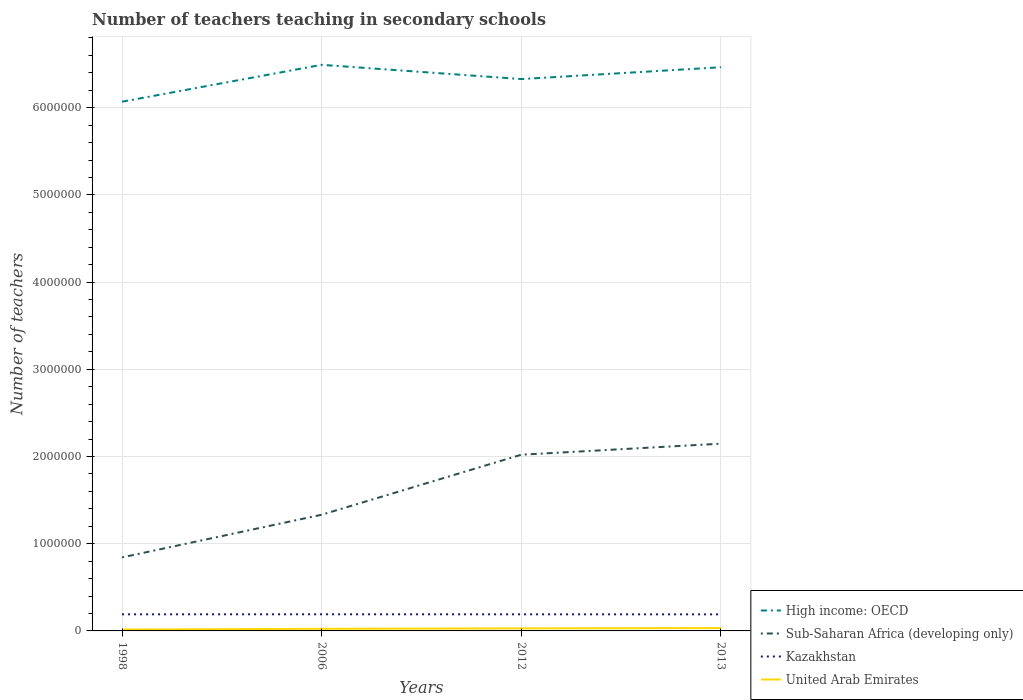Does the line corresponding to High income: OECD intersect with the line corresponding to Kazakhstan?
Provide a short and direct response. No. Across all years, what is the maximum number of teachers teaching in secondary schools in United Arab Emirates?
Offer a very short reply. 1.56e+04. What is the total number of teachers teaching in secondary schools in Kazakhstan in the graph?
Your response must be concise. 504. What is the difference between the highest and the second highest number of teachers teaching in secondary schools in United Arab Emirates?
Give a very brief answer. 1.71e+04. How many lines are there?
Your response must be concise. 4. What is the difference between two consecutive major ticks on the Y-axis?
Your answer should be compact. 1.00e+06. Are the values on the major ticks of Y-axis written in scientific E-notation?
Your answer should be compact. No. Does the graph contain any zero values?
Make the answer very short. No. What is the title of the graph?
Provide a short and direct response. Number of teachers teaching in secondary schools. Does "Peru" appear as one of the legend labels in the graph?
Keep it short and to the point. No. What is the label or title of the X-axis?
Give a very brief answer. Years. What is the label or title of the Y-axis?
Make the answer very short. Number of teachers. What is the Number of teachers of High income: OECD in 1998?
Your answer should be compact. 6.07e+06. What is the Number of teachers of Sub-Saharan Africa (developing only) in 1998?
Offer a terse response. 8.43e+05. What is the Number of teachers of Kazakhstan in 1998?
Your response must be concise. 1.90e+05. What is the Number of teachers in United Arab Emirates in 1998?
Your response must be concise. 1.56e+04. What is the Number of teachers of High income: OECD in 2006?
Make the answer very short. 6.49e+06. What is the Number of teachers in Sub-Saharan Africa (developing only) in 2006?
Make the answer very short. 1.33e+06. What is the Number of teachers in Kazakhstan in 2006?
Your answer should be compact. 1.91e+05. What is the Number of teachers in United Arab Emirates in 2006?
Your answer should be very brief. 2.42e+04. What is the Number of teachers of High income: OECD in 2012?
Your answer should be compact. 6.33e+06. What is the Number of teachers of Sub-Saharan Africa (developing only) in 2012?
Provide a short and direct response. 2.02e+06. What is the Number of teachers of Kazakhstan in 2012?
Provide a succinct answer. 1.90e+05. What is the Number of teachers in United Arab Emirates in 2012?
Your answer should be very brief. 2.93e+04. What is the Number of teachers in High income: OECD in 2013?
Your answer should be very brief. 6.46e+06. What is the Number of teachers of Sub-Saharan Africa (developing only) in 2013?
Provide a succinct answer. 2.15e+06. What is the Number of teachers in Kazakhstan in 2013?
Provide a short and direct response. 1.90e+05. What is the Number of teachers in United Arab Emirates in 2013?
Offer a terse response. 3.27e+04. Across all years, what is the maximum Number of teachers in High income: OECD?
Offer a very short reply. 6.49e+06. Across all years, what is the maximum Number of teachers of Sub-Saharan Africa (developing only)?
Your response must be concise. 2.15e+06. Across all years, what is the maximum Number of teachers in Kazakhstan?
Provide a succinct answer. 1.91e+05. Across all years, what is the maximum Number of teachers in United Arab Emirates?
Offer a very short reply. 3.27e+04. Across all years, what is the minimum Number of teachers of High income: OECD?
Give a very brief answer. 6.07e+06. Across all years, what is the minimum Number of teachers of Sub-Saharan Africa (developing only)?
Your answer should be very brief. 8.43e+05. Across all years, what is the minimum Number of teachers in Kazakhstan?
Give a very brief answer. 1.90e+05. Across all years, what is the minimum Number of teachers of United Arab Emirates?
Provide a succinct answer. 1.56e+04. What is the total Number of teachers of High income: OECD in the graph?
Give a very brief answer. 2.54e+07. What is the total Number of teachers in Sub-Saharan Africa (developing only) in the graph?
Make the answer very short. 6.34e+06. What is the total Number of teachers in Kazakhstan in the graph?
Provide a short and direct response. 7.62e+05. What is the total Number of teachers of United Arab Emirates in the graph?
Your answer should be compact. 1.02e+05. What is the difference between the Number of teachers of High income: OECD in 1998 and that in 2006?
Offer a terse response. -4.23e+05. What is the difference between the Number of teachers of Sub-Saharan Africa (developing only) in 1998 and that in 2006?
Your response must be concise. -4.89e+05. What is the difference between the Number of teachers in Kazakhstan in 1998 and that in 2006?
Your answer should be compact. -324. What is the difference between the Number of teachers in United Arab Emirates in 1998 and that in 2006?
Keep it short and to the point. -8642. What is the difference between the Number of teachers in High income: OECD in 1998 and that in 2012?
Provide a succinct answer. -2.59e+05. What is the difference between the Number of teachers in Sub-Saharan Africa (developing only) in 1998 and that in 2012?
Make the answer very short. -1.18e+06. What is the difference between the Number of teachers of Kazakhstan in 1998 and that in 2012?
Give a very brief answer. -23. What is the difference between the Number of teachers of United Arab Emirates in 1998 and that in 2012?
Provide a succinct answer. -1.37e+04. What is the difference between the Number of teachers in High income: OECD in 1998 and that in 2013?
Your answer should be compact. -3.95e+05. What is the difference between the Number of teachers in Sub-Saharan Africa (developing only) in 1998 and that in 2013?
Keep it short and to the point. -1.30e+06. What is the difference between the Number of teachers of Kazakhstan in 1998 and that in 2013?
Provide a succinct answer. 481. What is the difference between the Number of teachers in United Arab Emirates in 1998 and that in 2013?
Provide a short and direct response. -1.71e+04. What is the difference between the Number of teachers in High income: OECD in 2006 and that in 2012?
Provide a succinct answer. 1.64e+05. What is the difference between the Number of teachers of Sub-Saharan Africa (developing only) in 2006 and that in 2012?
Make the answer very short. -6.88e+05. What is the difference between the Number of teachers in Kazakhstan in 2006 and that in 2012?
Keep it short and to the point. 301. What is the difference between the Number of teachers of United Arab Emirates in 2006 and that in 2012?
Keep it short and to the point. -5061. What is the difference between the Number of teachers in High income: OECD in 2006 and that in 2013?
Make the answer very short. 2.78e+04. What is the difference between the Number of teachers of Sub-Saharan Africa (developing only) in 2006 and that in 2013?
Your answer should be very brief. -8.15e+05. What is the difference between the Number of teachers in Kazakhstan in 2006 and that in 2013?
Give a very brief answer. 805. What is the difference between the Number of teachers of United Arab Emirates in 2006 and that in 2013?
Offer a terse response. -8488. What is the difference between the Number of teachers in High income: OECD in 2012 and that in 2013?
Give a very brief answer. -1.36e+05. What is the difference between the Number of teachers of Sub-Saharan Africa (developing only) in 2012 and that in 2013?
Your answer should be very brief. -1.27e+05. What is the difference between the Number of teachers of Kazakhstan in 2012 and that in 2013?
Ensure brevity in your answer.  504. What is the difference between the Number of teachers of United Arab Emirates in 2012 and that in 2013?
Give a very brief answer. -3427. What is the difference between the Number of teachers in High income: OECD in 1998 and the Number of teachers in Sub-Saharan Africa (developing only) in 2006?
Offer a terse response. 4.74e+06. What is the difference between the Number of teachers of High income: OECD in 1998 and the Number of teachers of Kazakhstan in 2006?
Make the answer very short. 5.88e+06. What is the difference between the Number of teachers in High income: OECD in 1998 and the Number of teachers in United Arab Emirates in 2006?
Offer a very short reply. 6.04e+06. What is the difference between the Number of teachers in Sub-Saharan Africa (developing only) in 1998 and the Number of teachers in Kazakhstan in 2006?
Offer a terse response. 6.53e+05. What is the difference between the Number of teachers in Sub-Saharan Africa (developing only) in 1998 and the Number of teachers in United Arab Emirates in 2006?
Your answer should be very brief. 8.19e+05. What is the difference between the Number of teachers in Kazakhstan in 1998 and the Number of teachers in United Arab Emirates in 2006?
Keep it short and to the point. 1.66e+05. What is the difference between the Number of teachers in High income: OECD in 1998 and the Number of teachers in Sub-Saharan Africa (developing only) in 2012?
Your response must be concise. 4.05e+06. What is the difference between the Number of teachers in High income: OECD in 1998 and the Number of teachers in Kazakhstan in 2012?
Provide a succinct answer. 5.88e+06. What is the difference between the Number of teachers in High income: OECD in 1998 and the Number of teachers in United Arab Emirates in 2012?
Ensure brevity in your answer.  6.04e+06. What is the difference between the Number of teachers in Sub-Saharan Africa (developing only) in 1998 and the Number of teachers in Kazakhstan in 2012?
Offer a terse response. 6.53e+05. What is the difference between the Number of teachers in Sub-Saharan Africa (developing only) in 1998 and the Number of teachers in United Arab Emirates in 2012?
Provide a short and direct response. 8.14e+05. What is the difference between the Number of teachers of Kazakhstan in 1998 and the Number of teachers of United Arab Emirates in 2012?
Provide a succinct answer. 1.61e+05. What is the difference between the Number of teachers in High income: OECD in 1998 and the Number of teachers in Sub-Saharan Africa (developing only) in 2013?
Offer a terse response. 3.92e+06. What is the difference between the Number of teachers of High income: OECD in 1998 and the Number of teachers of Kazakhstan in 2013?
Your answer should be very brief. 5.88e+06. What is the difference between the Number of teachers of High income: OECD in 1998 and the Number of teachers of United Arab Emirates in 2013?
Provide a succinct answer. 6.04e+06. What is the difference between the Number of teachers in Sub-Saharan Africa (developing only) in 1998 and the Number of teachers in Kazakhstan in 2013?
Provide a succinct answer. 6.53e+05. What is the difference between the Number of teachers in Sub-Saharan Africa (developing only) in 1998 and the Number of teachers in United Arab Emirates in 2013?
Keep it short and to the point. 8.11e+05. What is the difference between the Number of teachers of Kazakhstan in 1998 and the Number of teachers of United Arab Emirates in 2013?
Ensure brevity in your answer.  1.58e+05. What is the difference between the Number of teachers in High income: OECD in 2006 and the Number of teachers in Sub-Saharan Africa (developing only) in 2012?
Keep it short and to the point. 4.47e+06. What is the difference between the Number of teachers in High income: OECD in 2006 and the Number of teachers in Kazakhstan in 2012?
Provide a short and direct response. 6.30e+06. What is the difference between the Number of teachers of High income: OECD in 2006 and the Number of teachers of United Arab Emirates in 2012?
Your answer should be compact. 6.46e+06. What is the difference between the Number of teachers in Sub-Saharan Africa (developing only) in 2006 and the Number of teachers in Kazakhstan in 2012?
Your response must be concise. 1.14e+06. What is the difference between the Number of teachers of Sub-Saharan Africa (developing only) in 2006 and the Number of teachers of United Arab Emirates in 2012?
Offer a terse response. 1.30e+06. What is the difference between the Number of teachers in Kazakhstan in 2006 and the Number of teachers in United Arab Emirates in 2012?
Make the answer very short. 1.62e+05. What is the difference between the Number of teachers of High income: OECD in 2006 and the Number of teachers of Sub-Saharan Africa (developing only) in 2013?
Provide a short and direct response. 4.34e+06. What is the difference between the Number of teachers of High income: OECD in 2006 and the Number of teachers of Kazakhstan in 2013?
Offer a terse response. 6.30e+06. What is the difference between the Number of teachers in High income: OECD in 2006 and the Number of teachers in United Arab Emirates in 2013?
Make the answer very short. 6.46e+06. What is the difference between the Number of teachers in Sub-Saharan Africa (developing only) in 2006 and the Number of teachers in Kazakhstan in 2013?
Keep it short and to the point. 1.14e+06. What is the difference between the Number of teachers in Sub-Saharan Africa (developing only) in 2006 and the Number of teachers in United Arab Emirates in 2013?
Ensure brevity in your answer.  1.30e+06. What is the difference between the Number of teachers of Kazakhstan in 2006 and the Number of teachers of United Arab Emirates in 2013?
Make the answer very short. 1.58e+05. What is the difference between the Number of teachers in High income: OECD in 2012 and the Number of teachers in Sub-Saharan Africa (developing only) in 2013?
Make the answer very short. 4.18e+06. What is the difference between the Number of teachers of High income: OECD in 2012 and the Number of teachers of Kazakhstan in 2013?
Provide a short and direct response. 6.14e+06. What is the difference between the Number of teachers of High income: OECD in 2012 and the Number of teachers of United Arab Emirates in 2013?
Provide a short and direct response. 6.30e+06. What is the difference between the Number of teachers in Sub-Saharan Africa (developing only) in 2012 and the Number of teachers in Kazakhstan in 2013?
Make the answer very short. 1.83e+06. What is the difference between the Number of teachers in Sub-Saharan Africa (developing only) in 2012 and the Number of teachers in United Arab Emirates in 2013?
Ensure brevity in your answer.  1.99e+06. What is the difference between the Number of teachers in Kazakhstan in 2012 and the Number of teachers in United Arab Emirates in 2013?
Your response must be concise. 1.58e+05. What is the average Number of teachers in High income: OECD per year?
Provide a succinct answer. 6.34e+06. What is the average Number of teachers of Sub-Saharan Africa (developing only) per year?
Give a very brief answer. 1.59e+06. What is the average Number of teachers of Kazakhstan per year?
Your answer should be compact. 1.90e+05. What is the average Number of teachers of United Arab Emirates per year?
Your answer should be very brief. 2.54e+04. In the year 1998, what is the difference between the Number of teachers of High income: OECD and Number of teachers of Sub-Saharan Africa (developing only)?
Make the answer very short. 5.23e+06. In the year 1998, what is the difference between the Number of teachers in High income: OECD and Number of teachers in Kazakhstan?
Provide a short and direct response. 5.88e+06. In the year 1998, what is the difference between the Number of teachers in High income: OECD and Number of teachers in United Arab Emirates?
Your answer should be very brief. 6.05e+06. In the year 1998, what is the difference between the Number of teachers of Sub-Saharan Africa (developing only) and Number of teachers of Kazakhstan?
Your response must be concise. 6.53e+05. In the year 1998, what is the difference between the Number of teachers of Sub-Saharan Africa (developing only) and Number of teachers of United Arab Emirates?
Your response must be concise. 8.28e+05. In the year 1998, what is the difference between the Number of teachers of Kazakhstan and Number of teachers of United Arab Emirates?
Your answer should be compact. 1.75e+05. In the year 2006, what is the difference between the Number of teachers in High income: OECD and Number of teachers in Sub-Saharan Africa (developing only)?
Offer a terse response. 5.16e+06. In the year 2006, what is the difference between the Number of teachers of High income: OECD and Number of teachers of Kazakhstan?
Give a very brief answer. 6.30e+06. In the year 2006, what is the difference between the Number of teachers of High income: OECD and Number of teachers of United Arab Emirates?
Your response must be concise. 6.47e+06. In the year 2006, what is the difference between the Number of teachers of Sub-Saharan Africa (developing only) and Number of teachers of Kazakhstan?
Your response must be concise. 1.14e+06. In the year 2006, what is the difference between the Number of teachers in Sub-Saharan Africa (developing only) and Number of teachers in United Arab Emirates?
Offer a terse response. 1.31e+06. In the year 2006, what is the difference between the Number of teachers of Kazakhstan and Number of teachers of United Arab Emirates?
Offer a very short reply. 1.67e+05. In the year 2012, what is the difference between the Number of teachers of High income: OECD and Number of teachers of Sub-Saharan Africa (developing only)?
Give a very brief answer. 4.31e+06. In the year 2012, what is the difference between the Number of teachers of High income: OECD and Number of teachers of Kazakhstan?
Provide a succinct answer. 6.14e+06. In the year 2012, what is the difference between the Number of teachers in High income: OECD and Number of teachers in United Arab Emirates?
Provide a short and direct response. 6.30e+06. In the year 2012, what is the difference between the Number of teachers in Sub-Saharan Africa (developing only) and Number of teachers in Kazakhstan?
Give a very brief answer. 1.83e+06. In the year 2012, what is the difference between the Number of teachers in Sub-Saharan Africa (developing only) and Number of teachers in United Arab Emirates?
Give a very brief answer. 1.99e+06. In the year 2012, what is the difference between the Number of teachers in Kazakhstan and Number of teachers in United Arab Emirates?
Make the answer very short. 1.61e+05. In the year 2013, what is the difference between the Number of teachers in High income: OECD and Number of teachers in Sub-Saharan Africa (developing only)?
Ensure brevity in your answer.  4.32e+06. In the year 2013, what is the difference between the Number of teachers in High income: OECD and Number of teachers in Kazakhstan?
Your response must be concise. 6.27e+06. In the year 2013, what is the difference between the Number of teachers in High income: OECD and Number of teachers in United Arab Emirates?
Provide a short and direct response. 6.43e+06. In the year 2013, what is the difference between the Number of teachers in Sub-Saharan Africa (developing only) and Number of teachers in Kazakhstan?
Your answer should be compact. 1.96e+06. In the year 2013, what is the difference between the Number of teachers in Sub-Saharan Africa (developing only) and Number of teachers in United Arab Emirates?
Your answer should be compact. 2.11e+06. In the year 2013, what is the difference between the Number of teachers of Kazakhstan and Number of teachers of United Arab Emirates?
Keep it short and to the point. 1.57e+05. What is the ratio of the Number of teachers of High income: OECD in 1998 to that in 2006?
Ensure brevity in your answer.  0.93. What is the ratio of the Number of teachers of Sub-Saharan Africa (developing only) in 1998 to that in 2006?
Provide a short and direct response. 0.63. What is the ratio of the Number of teachers in United Arab Emirates in 1998 to that in 2006?
Offer a terse response. 0.64. What is the ratio of the Number of teachers in High income: OECD in 1998 to that in 2012?
Your answer should be very brief. 0.96. What is the ratio of the Number of teachers of Sub-Saharan Africa (developing only) in 1998 to that in 2012?
Provide a short and direct response. 0.42. What is the ratio of the Number of teachers of United Arab Emirates in 1998 to that in 2012?
Keep it short and to the point. 0.53. What is the ratio of the Number of teachers in High income: OECD in 1998 to that in 2013?
Keep it short and to the point. 0.94. What is the ratio of the Number of teachers in Sub-Saharan Africa (developing only) in 1998 to that in 2013?
Ensure brevity in your answer.  0.39. What is the ratio of the Number of teachers of United Arab Emirates in 1998 to that in 2013?
Your answer should be very brief. 0.48. What is the ratio of the Number of teachers in High income: OECD in 2006 to that in 2012?
Your answer should be compact. 1.03. What is the ratio of the Number of teachers in Sub-Saharan Africa (developing only) in 2006 to that in 2012?
Ensure brevity in your answer.  0.66. What is the ratio of the Number of teachers in Kazakhstan in 2006 to that in 2012?
Your response must be concise. 1. What is the ratio of the Number of teachers in United Arab Emirates in 2006 to that in 2012?
Offer a terse response. 0.83. What is the ratio of the Number of teachers in High income: OECD in 2006 to that in 2013?
Your answer should be very brief. 1. What is the ratio of the Number of teachers in Sub-Saharan Africa (developing only) in 2006 to that in 2013?
Offer a terse response. 0.62. What is the ratio of the Number of teachers of Kazakhstan in 2006 to that in 2013?
Provide a short and direct response. 1. What is the ratio of the Number of teachers in United Arab Emirates in 2006 to that in 2013?
Offer a terse response. 0.74. What is the ratio of the Number of teachers of High income: OECD in 2012 to that in 2013?
Make the answer very short. 0.98. What is the ratio of the Number of teachers in Sub-Saharan Africa (developing only) in 2012 to that in 2013?
Offer a terse response. 0.94. What is the ratio of the Number of teachers of Kazakhstan in 2012 to that in 2013?
Offer a very short reply. 1. What is the ratio of the Number of teachers of United Arab Emirates in 2012 to that in 2013?
Give a very brief answer. 0.9. What is the difference between the highest and the second highest Number of teachers of High income: OECD?
Your response must be concise. 2.78e+04. What is the difference between the highest and the second highest Number of teachers in Sub-Saharan Africa (developing only)?
Keep it short and to the point. 1.27e+05. What is the difference between the highest and the second highest Number of teachers in Kazakhstan?
Offer a very short reply. 301. What is the difference between the highest and the second highest Number of teachers of United Arab Emirates?
Offer a very short reply. 3427. What is the difference between the highest and the lowest Number of teachers in High income: OECD?
Offer a very short reply. 4.23e+05. What is the difference between the highest and the lowest Number of teachers of Sub-Saharan Africa (developing only)?
Provide a succinct answer. 1.30e+06. What is the difference between the highest and the lowest Number of teachers in Kazakhstan?
Make the answer very short. 805. What is the difference between the highest and the lowest Number of teachers of United Arab Emirates?
Offer a terse response. 1.71e+04. 